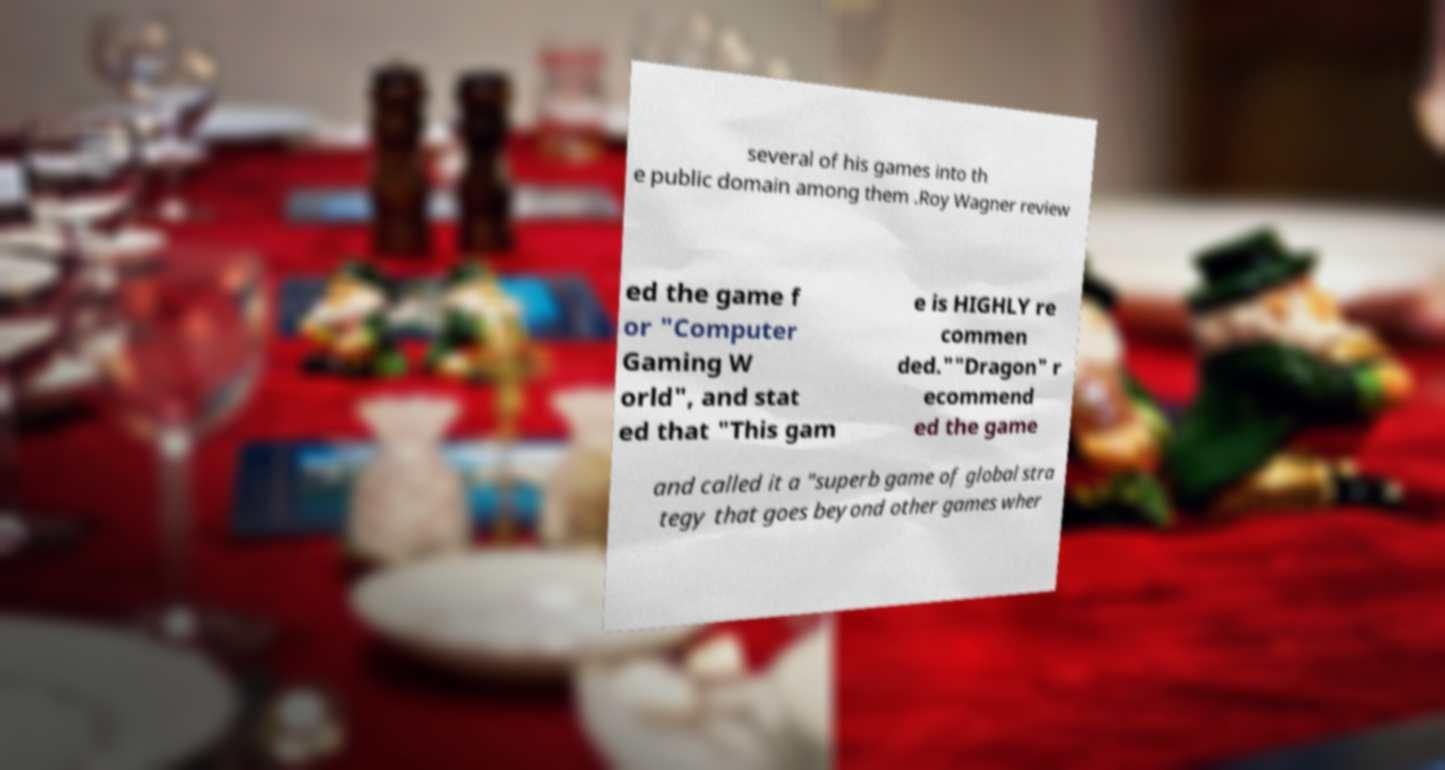Can you accurately transcribe the text from the provided image for me? several of his games into th e public domain among them .Roy Wagner review ed the game f or "Computer Gaming W orld", and stat ed that "This gam e is HIGHLY re commen ded.""Dragon" r ecommend ed the game and called it a "superb game of global stra tegy that goes beyond other games wher 